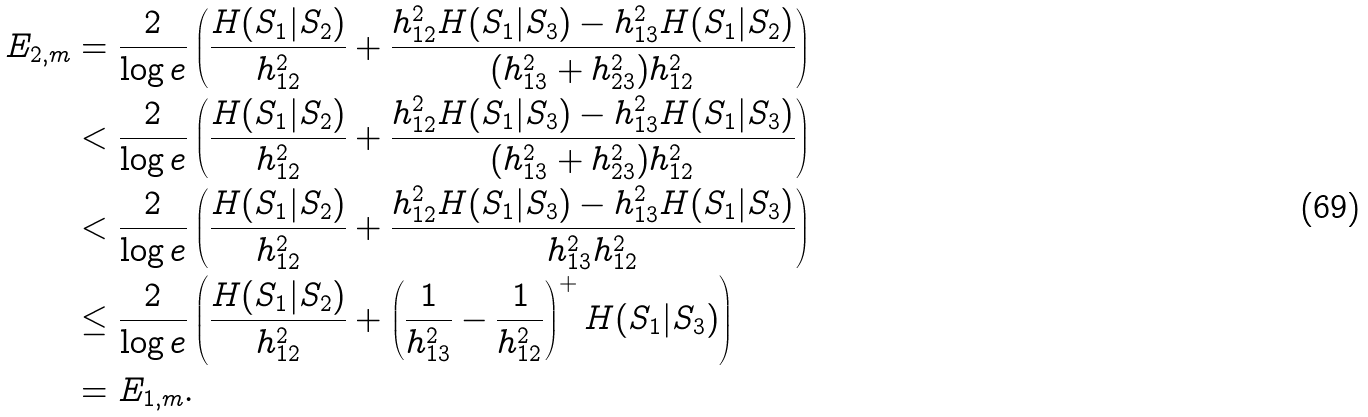<formula> <loc_0><loc_0><loc_500><loc_500>E _ { 2 , m } & = \frac { 2 } { \log e } \left ( \frac { H ( S _ { 1 } | S _ { 2 } ) } { h _ { 1 2 } ^ { 2 } } + \frac { h _ { 1 2 } ^ { 2 } H ( S _ { 1 } | S _ { 3 } ) - h _ { 1 3 } ^ { 2 } H ( S _ { 1 } | S _ { 2 } ) } { ( h _ { 1 3 } ^ { 2 } + h _ { 2 3 } ^ { 2 } ) h _ { 1 2 } ^ { 2 } } \right ) \\ & < \frac { 2 } { \log e } \left ( \frac { H ( S _ { 1 } | S _ { 2 } ) } { h _ { 1 2 } ^ { 2 } } + \frac { h _ { 1 2 } ^ { 2 } H ( S _ { 1 } | S _ { 3 } ) - h _ { 1 3 } ^ { 2 } H ( S _ { 1 } | S _ { 3 } ) } { ( h _ { 1 3 } ^ { 2 } + h _ { 2 3 } ^ { 2 } ) h _ { 1 2 } ^ { 2 } } \right ) \\ & < \frac { 2 } { \log e } \left ( \frac { H ( S _ { 1 } | S _ { 2 } ) } { h _ { 1 2 } ^ { 2 } } + \frac { h _ { 1 2 } ^ { 2 } H ( S _ { 1 } | S _ { 3 } ) - h _ { 1 3 } ^ { 2 } H ( S _ { 1 } | S _ { 3 } ) } { h _ { 1 3 } ^ { 2 } h _ { 1 2 } ^ { 2 } } \right ) \\ & \leq \frac { 2 } { \log e } \left ( \frac { H ( S _ { 1 } | S _ { 2 } ) } { h _ { 1 2 } ^ { 2 } } + \left ( \frac { 1 } { h _ { 1 3 } ^ { 2 } } - \frac { 1 } { h _ { 1 2 } ^ { 2 } } \right ) ^ { + } H ( S _ { 1 } | S _ { 3 } ) \right ) \\ & = E _ { 1 , m } .</formula> 